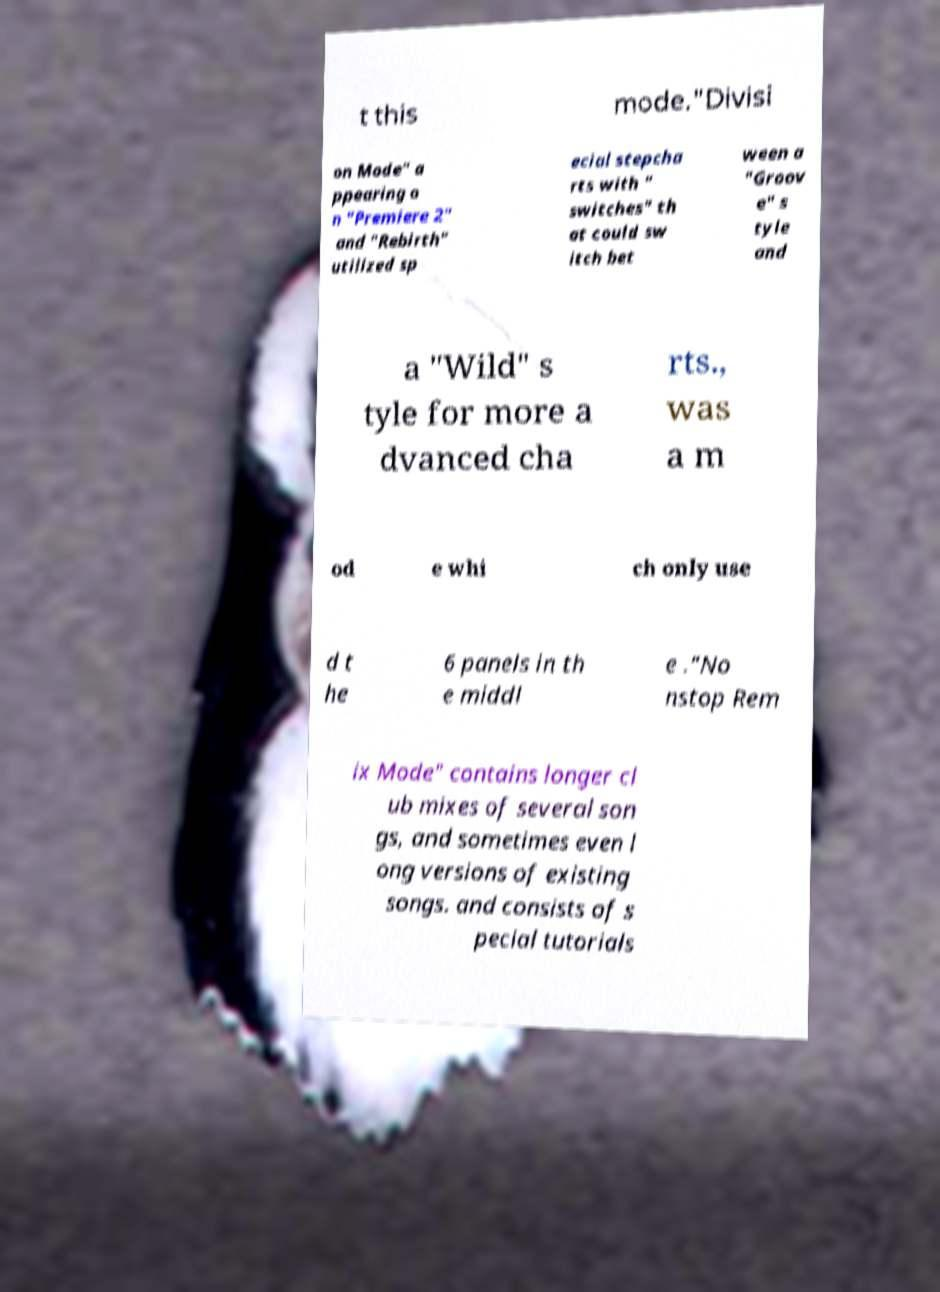Can you read and provide the text displayed in the image?This photo seems to have some interesting text. Can you extract and type it out for me? t this mode."Divisi on Mode" a ppearing o n "Premiere 2" and "Rebirth" utilized sp ecial stepcha rts with " switches" th at could sw itch bet ween a "Groov e" s tyle and a "Wild" s tyle for more a dvanced cha rts., was a m od e whi ch only use d t he 6 panels in th e middl e ."No nstop Rem ix Mode" contains longer cl ub mixes of several son gs, and sometimes even l ong versions of existing songs. and consists of s pecial tutorials 